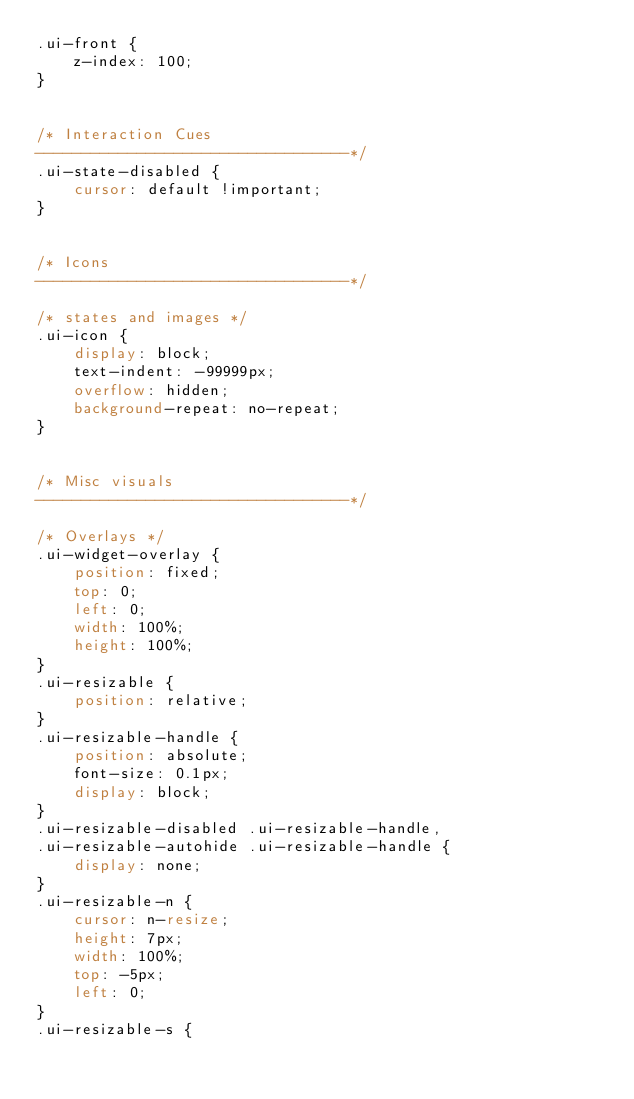Convert code to text. <code><loc_0><loc_0><loc_500><loc_500><_CSS_>.ui-front {
	z-index: 100;
}


/* Interaction Cues
----------------------------------*/
.ui-state-disabled {
	cursor: default !important;
}


/* Icons
----------------------------------*/

/* states and images */
.ui-icon {
	display: block;
	text-indent: -99999px;
	overflow: hidden;
	background-repeat: no-repeat;
}


/* Misc visuals
----------------------------------*/

/* Overlays */
.ui-widget-overlay {
	position: fixed;
	top: 0;
	left: 0;
	width: 100%;
	height: 100%;
}
.ui-resizable {
	position: relative;
}
.ui-resizable-handle {
	position: absolute;
	font-size: 0.1px;
	display: block;
}
.ui-resizable-disabled .ui-resizable-handle,
.ui-resizable-autohide .ui-resizable-handle {
	display: none;
}
.ui-resizable-n {
	cursor: n-resize;
	height: 7px;
	width: 100%;
	top: -5px;
	left: 0;
}
.ui-resizable-s {</code> 